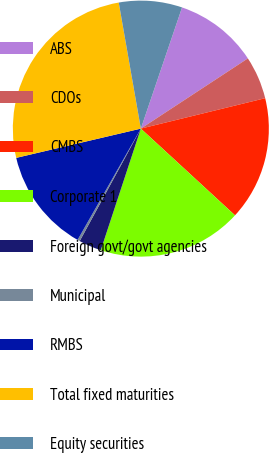Convert chart to OTSL. <chart><loc_0><loc_0><loc_500><loc_500><pie_chart><fcel>ABS<fcel>CDOs<fcel>CMBS<fcel>Corporate 1<fcel>Foreign govt/govt agencies<fcel>Municipal<fcel>RMBS<fcel>Total fixed maturities<fcel>Equity securities<nl><fcel>10.54%<fcel>5.42%<fcel>15.66%<fcel>18.22%<fcel>2.86%<fcel>0.3%<fcel>13.1%<fcel>25.9%<fcel>7.98%<nl></chart> 